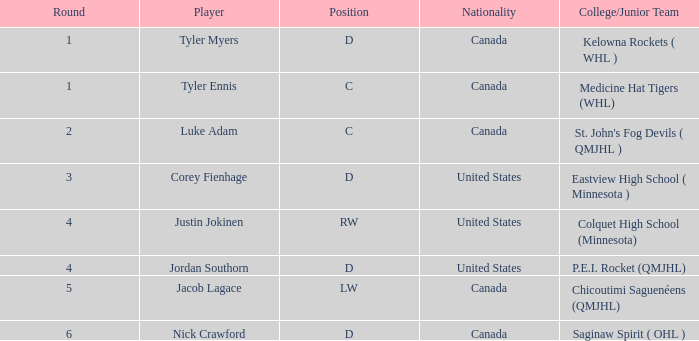What is the usual round for a us-based rw position player? 4.0. 